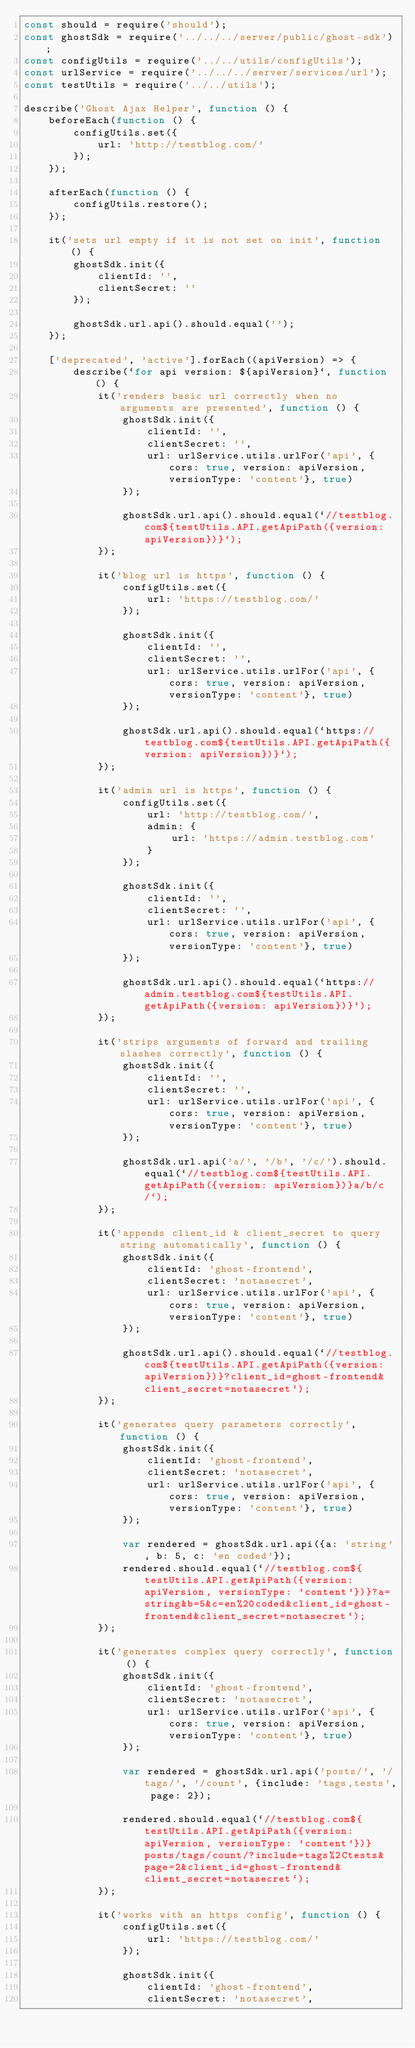<code> <loc_0><loc_0><loc_500><loc_500><_JavaScript_>const should = require('should');
const ghostSdk = require('../../../server/public/ghost-sdk');
const configUtils = require('../../utils/configUtils');
const urlService = require('../../../server/services/url');
const testUtils = require('../../utils');

describe('Ghost Ajax Helper', function () {
    beforeEach(function () {
        configUtils.set({
            url: 'http://testblog.com/'
        });
    });

    afterEach(function () {
        configUtils.restore();
    });

    it('sets url empty if it is not set on init', function () {
        ghostSdk.init({
            clientId: '',
            clientSecret: ''
        });

        ghostSdk.url.api().should.equal('');
    });

    ['deprecated', 'active'].forEach((apiVersion) => {
        describe(`for api version: ${apiVersion}`, function () {
            it('renders basic url correctly when no arguments are presented', function () {
                ghostSdk.init({
                    clientId: '',
                    clientSecret: '',
                    url: urlService.utils.urlFor('api', {cors: true, version: apiVersion, versionType: 'content'}, true)
                });

                ghostSdk.url.api().should.equal(`//testblog.com${testUtils.API.getApiPath({version: apiVersion})}`);
            });

            it('blog url is https', function () {
                configUtils.set({
                    url: 'https://testblog.com/'
                });

                ghostSdk.init({
                    clientId: '',
                    clientSecret: '',
                    url: urlService.utils.urlFor('api', {cors: true, version: apiVersion, versionType: 'content'}, true)
                });

                ghostSdk.url.api().should.equal(`https://testblog.com${testUtils.API.getApiPath({version: apiVersion})}`);
            });

            it('admin url is https', function () {
                configUtils.set({
                    url: 'http://testblog.com/',
                    admin: {
                        url: 'https://admin.testblog.com'
                    }
                });

                ghostSdk.init({
                    clientId: '',
                    clientSecret: '',
                    url: urlService.utils.urlFor('api', {cors: true, version: apiVersion, versionType: 'content'}, true)
                });

                ghostSdk.url.api().should.equal(`https://admin.testblog.com${testUtils.API.getApiPath({version: apiVersion})}`);
            });

            it('strips arguments of forward and trailing slashes correctly', function () {
                ghostSdk.init({
                    clientId: '',
                    clientSecret: '',
                    url: urlService.utils.urlFor('api', {cors: true, version: apiVersion, versionType: 'content'}, true)
                });

                ghostSdk.url.api('a/', '/b', '/c/').should.equal(`//testblog.com${testUtils.API.getApiPath({version: apiVersion})}a/b/c/`);
            });

            it('appends client_id & client_secret to query string automatically', function () {
                ghostSdk.init({
                    clientId: 'ghost-frontend',
                    clientSecret: 'notasecret',
                    url: urlService.utils.urlFor('api', {cors: true, version: apiVersion, versionType: 'content'}, true)
                });

                ghostSdk.url.api().should.equal(`//testblog.com${testUtils.API.getApiPath({version: apiVersion})}?client_id=ghost-frontend&client_secret=notasecret`);
            });

            it('generates query parameters correctly', function () {
                ghostSdk.init({
                    clientId: 'ghost-frontend',
                    clientSecret: 'notasecret',
                    url: urlService.utils.urlFor('api', {cors: true, version: apiVersion, versionType: 'content'}, true)
                });

                var rendered = ghostSdk.url.api({a: 'string', b: 5, c: 'en coded'});
                rendered.should.equal(`//testblog.com${testUtils.API.getApiPath({version: apiVersion, versionType: 'content'})}?a=string&b=5&c=en%20coded&client_id=ghost-frontend&client_secret=notasecret`);
            });

            it('generates complex query correctly', function () {
                ghostSdk.init({
                    clientId: 'ghost-frontend',
                    clientSecret: 'notasecret',
                    url: urlService.utils.urlFor('api', {cors: true, version: apiVersion, versionType: 'content'}, true)
                });

                var rendered = ghostSdk.url.api('posts/', '/tags/', '/count', {include: 'tags,tests', page: 2});

                rendered.should.equal(`//testblog.com${testUtils.API.getApiPath({version: apiVersion, versionType: 'content'})}posts/tags/count/?include=tags%2Ctests&page=2&client_id=ghost-frontend&client_secret=notasecret`);
            });

            it('works with an https config', function () {
                configUtils.set({
                    url: 'https://testblog.com/'
                });

                ghostSdk.init({
                    clientId: 'ghost-frontend',
                    clientSecret: 'notasecret',</code> 